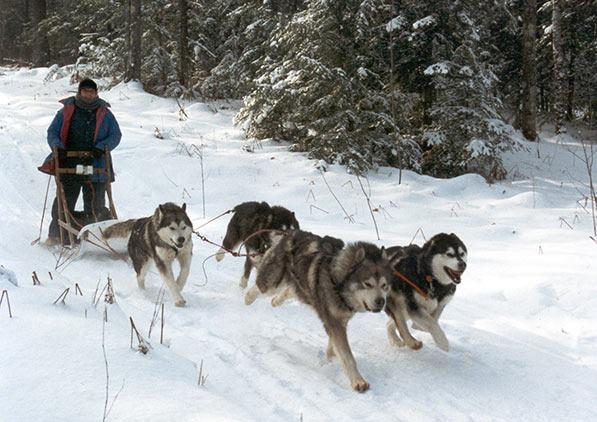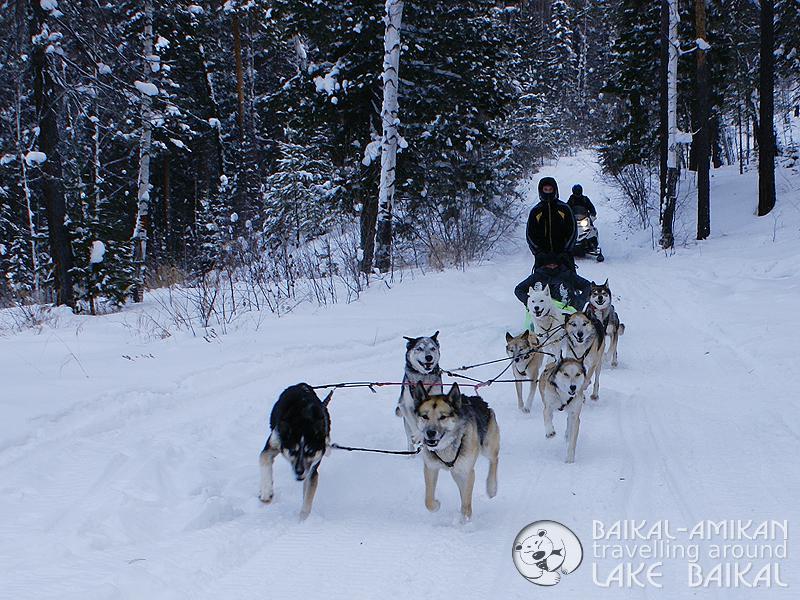The first image is the image on the left, the second image is the image on the right. For the images displayed, is the sentence "The right image shows a dog team moving rightward across the snow past a type of housing shelter on the right." factually correct? Answer yes or no. No. The first image is the image on the left, the second image is the image on the right. For the images shown, is this caption "In at least one image there are no more than four dogs dragging a single man with a black hat on the back of a sled." true? Answer yes or no. Yes. 